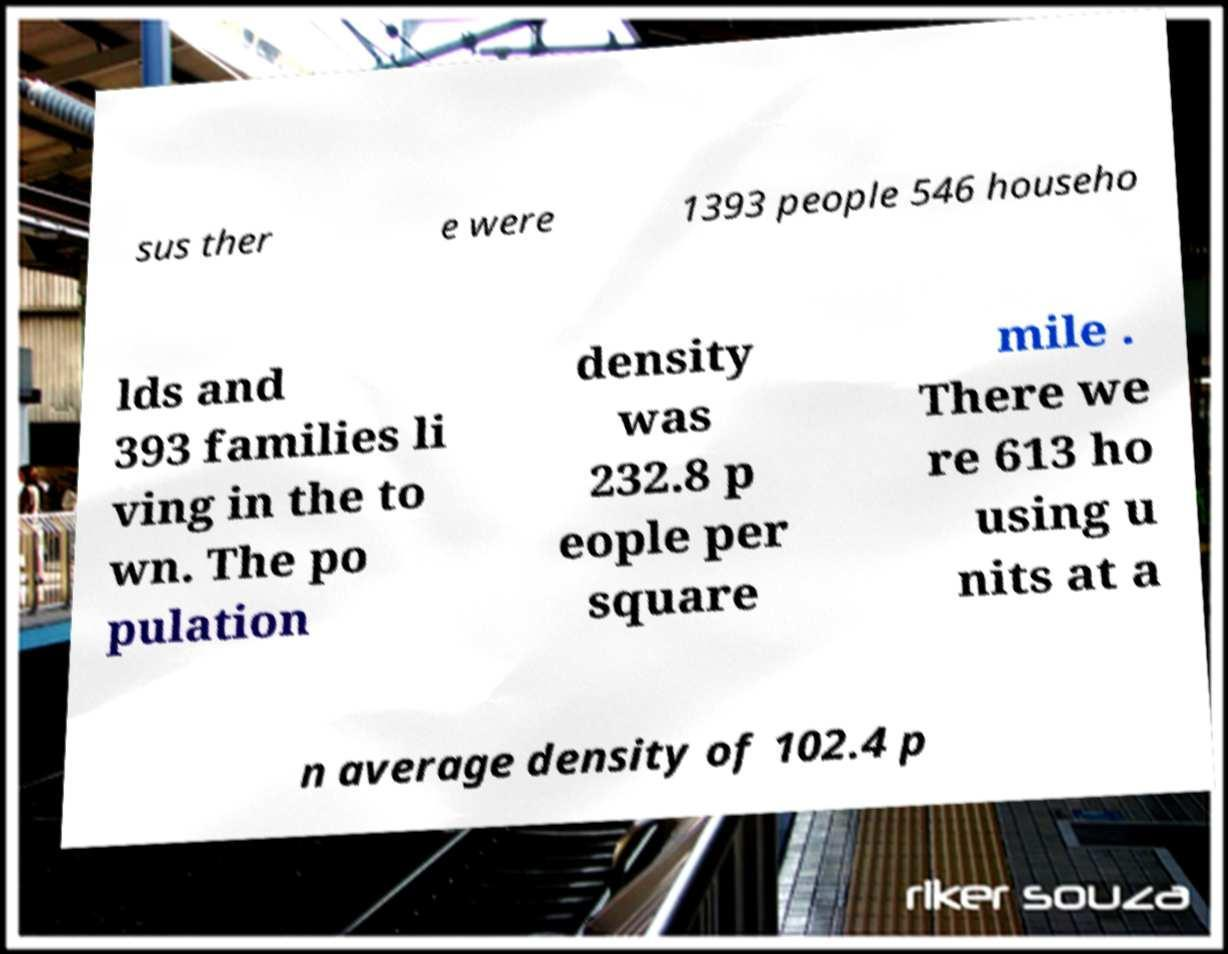For documentation purposes, I need the text within this image transcribed. Could you provide that? sus ther e were 1393 people 546 househo lds and 393 families li ving in the to wn. The po pulation density was 232.8 p eople per square mile . There we re 613 ho using u nits at a n average density of 102.4 p 